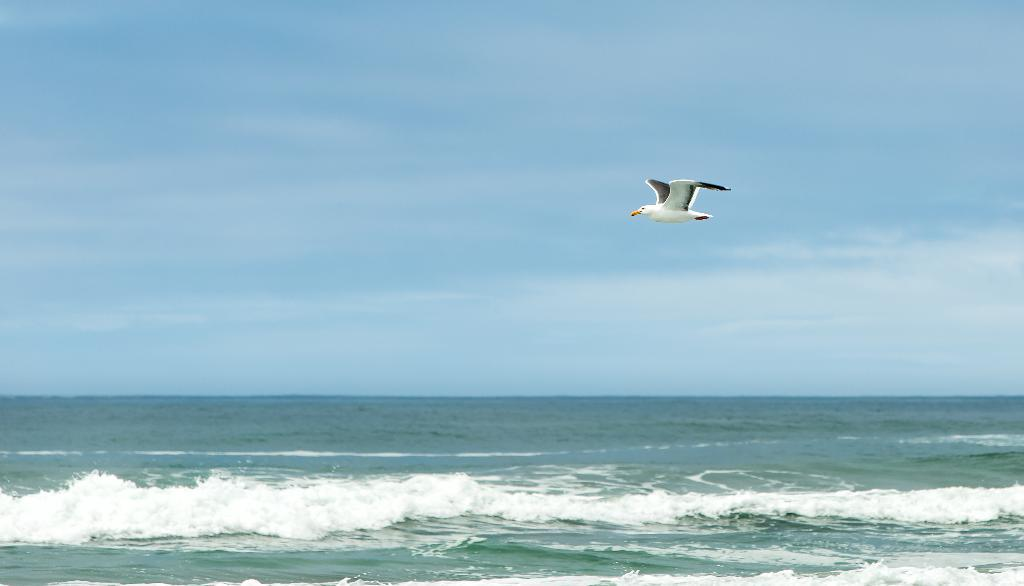What type of animal is in the image? There is a white bird in the image. What is the bird doing in the image? The bird is flying in the sky. What can be seen below the bird in the image? There is water visible below the bird. Can you find the receipt for the bird's purchase in the image? There is no receipt present in the image, as it is a photograph of a bird in flight. 